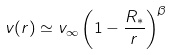<formula> <loc_0><loc_0><loc_500><loc_500>v ( r ) \simeq v _ { \infty } \left ( 1 - \frac { R _ { * } } { r } \right ) ^ { \beta }</formula> 